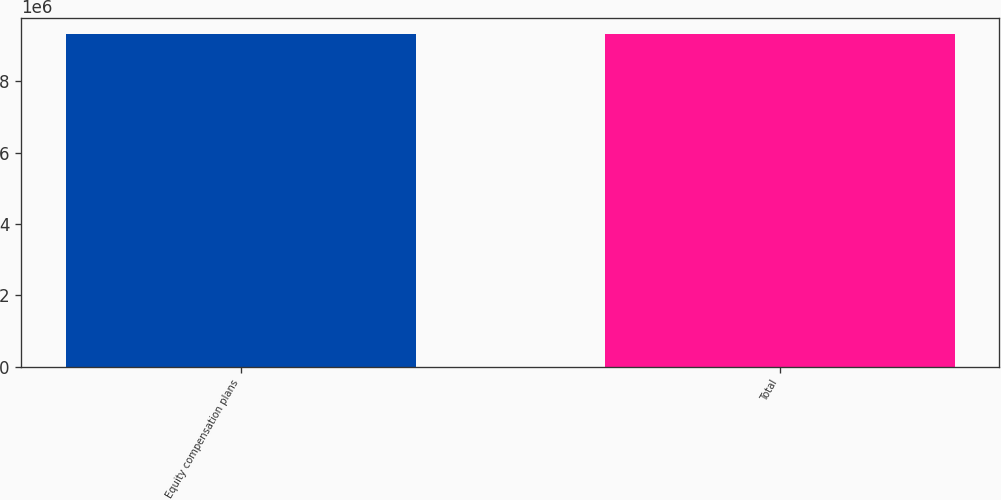Convert chart to OTSL. <chart><loc_0><loc_0><loc_500><loc_500><bar_chart><fcel>Equity compensation plans<fcel>Total<nl><fcel>9.31964e+06<fcel>9.31964e+06<nl></chart> 